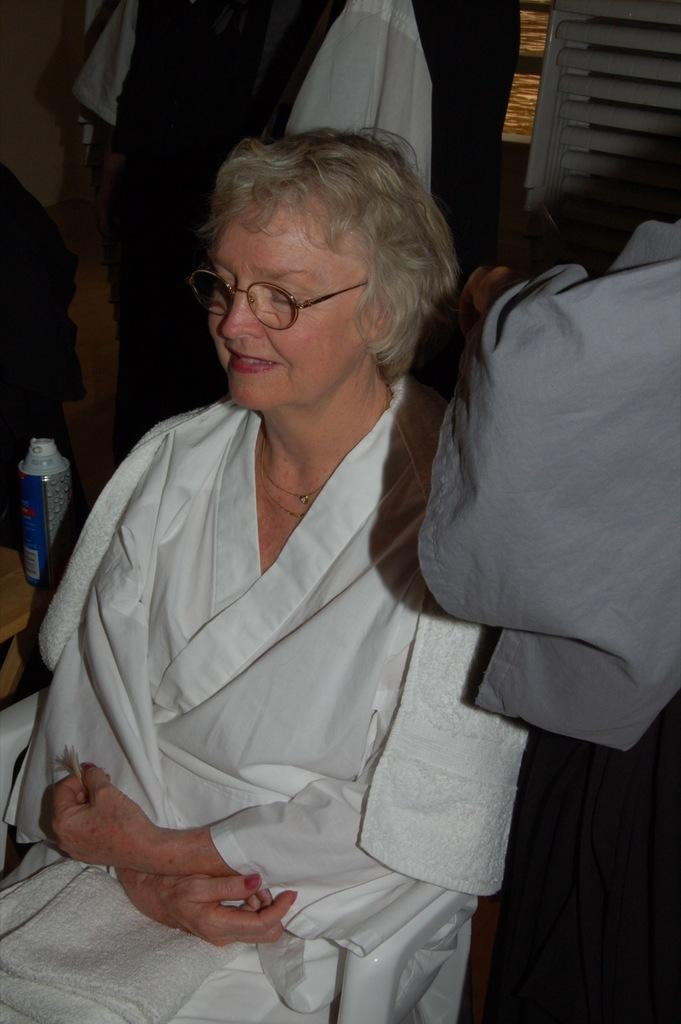What is the woman doing in the image? The woman is sitting on a chair in the image. How many people are present in the image? There is one person, a woman, present in the image. What is on the table in the image? There is a bottle on a table in the image. What can be seen in the background of the image? There are clothes and objects in the background of the image. How many pies are being served by the woman's legs in the image? There are no pies or legs visible in the image. What type of friction is present between the woman's chair and the floor in the image? The image does not provide information about the type of friction between the chair and the floor. 